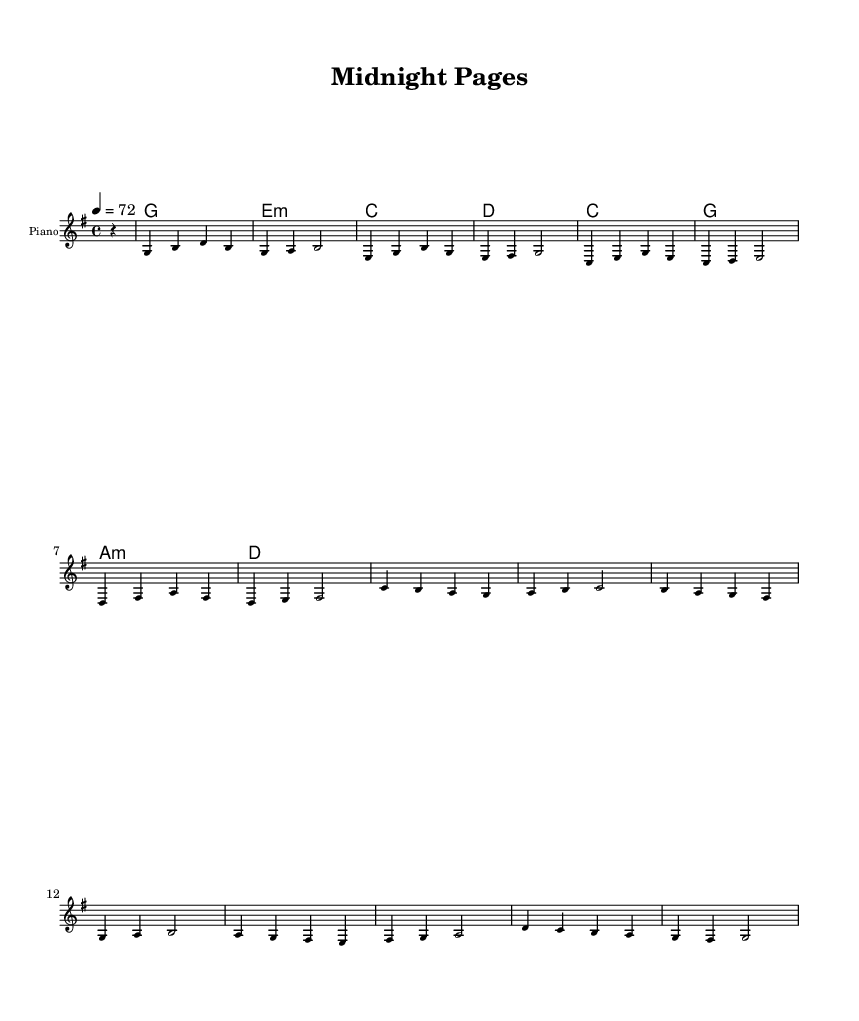What is the key signature of this music? The key signature is G major, which contains one sharp (F#). This is determined by examining the key signature mark at the beginning of the staff.
Answer: G major What is the time signature of this music? The time signature is 4/4, which indicates four beats in each measure, with a quarter note receiving one beat. This can be identified from the notation at the beginning of the score, appearing as a fraction of two numbers.
Answer: 4/4 What is the tempo marking of this piece? The tempo marking is 72 beats per minute, which is specified in the score as "4 = 72" under the tempo section. This indicates the speed at which the music should be played.
Answer: 72 How many measures are there in the melody? There are 16 measures in the melody, as counted by separating the sections between bar lines. Each distinct segment between the vertical lines represents one measure.
Answer: 16 What is the first chord played in the harmonies? The first chord is G major, which can be identified from the chord names written above the staff. The chord that appears first is indicated by the corresponding G at the start of the chord progression.
Answer: G How many distinct notes are in the first measure of the melody? There are three distinct notes (G, B, D) in the first measure of the melody. This is determined by identifying the different pitches that are played in that measure, indicated on the staff.
Answer: 3 What type of music structure is used in this piece? The music follows a verse-chorus structure typical of pop songs, which can be inferred by the repeated chord progressions and melodies designed for singability and catchiness.
Answer: Verse-chorus 